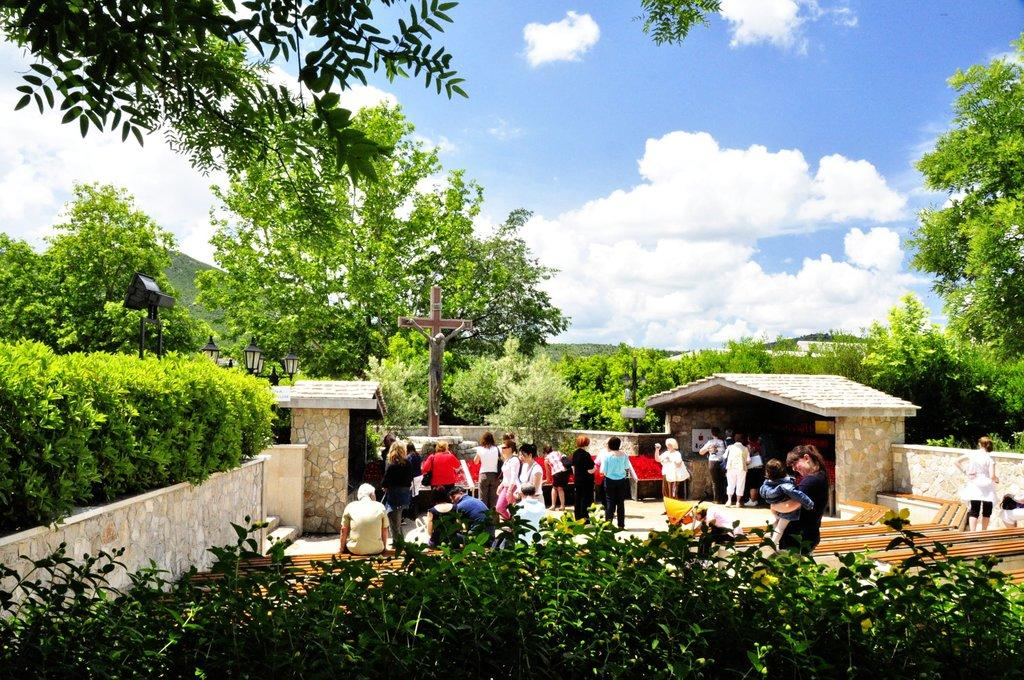What type of vegetation is at the bottom of the image? There are plants at the bottom of the image. What can be seen in the middle of the image? There is a fence, a crowd, poles, and trees in the middle of the image. What is visible at the top of the image? The sky is visible at the top of the image. What is the weather like in the image? The image was taken during a sunny day. How far away is the distance that the sticks are located in the image? There are no sticks present in the image. What type of precipitation can be seen falling from the sky in the image? The image was taken during a sunny day, so there is no precipitation visible. 